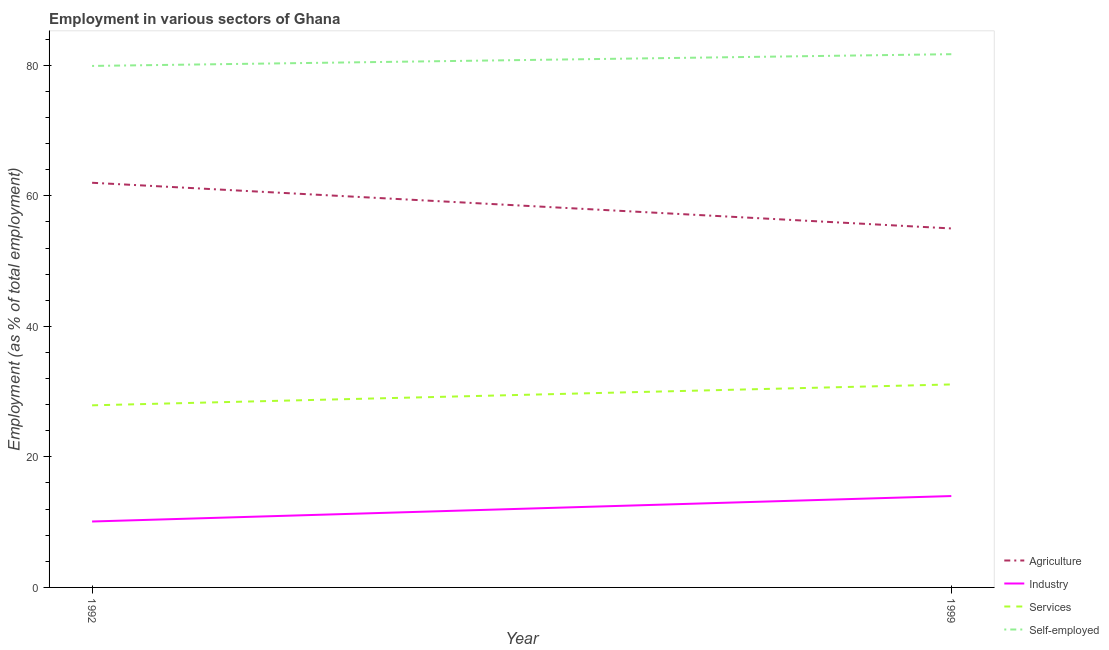How many different coloured lines are there?
Provide a succinct answer. 4. Across all years, what is the maximum percentage of workers in services?
Make the answer very short. 31.1. Across all years, what is the minimum percentage of self employed workers?
Your answer should be very brief. 79.9. In which year was the percentage of workers in industry minimum?
Provide a succinct answer. 1992. What is the total percentage of workers in industry in the graph?
Your answer should be very brief. 24.1. What is the difference between the percentage of workers in agriculture in 1992 and that in 1999?
Make the answer very short. 7. What is the difference between the percentage of workers in agriculture in 1992 and the percentage of workers in services in 1999?
Your response must be concise. 30.9. What is the average percentage of self employed workers per year?
Ensure brevity in your answer.  80.8. In the year 1999, what is the difference between the percentage of workers in agriculture and percentage of workers in services?
Your answer should be compact. 23.9. What is the ratio of the percentage of workers in agriculture in 1992 to that in 1999?
Provide a short and direct response. 1.13. In how many years, is the percentage of workers in agriculture greater than the average percentage of workers in agriculture taken over all years?
Your response must be concise. 1. Does the percentage of self employed workers monotonically increase over the years?
Make the answer very short. Yes. What is the difference between two consecutive major ticks on the Y-axis?
Your response must be concise. 20. Are the values on the major ticks of Y-axis written in scientific E-notation?
Your answer should be compact. No. Does the graph contain any zero values?
Your response must be concise. No. Where does the legend appear in the graph?
Your answer should be compact. Bottom right. How are the legend labels stacked?
Ensure brevity in your answer.  Vertical. What is the title of the graph?
Your answer should be compact. Employment in various sectors of Ghana. Does "Rule based governance" appear as one of the legend labels in the graph?
Make the answer very short. No. What is the label or title of the Y-axis?
Offer a very short reply. Employment (as % of total employment). What is the Employment (as % of total employment) of Industry in 1992?
Ensure brevity in your answer.  10.1. What is the Employment (as % of total employment) of Services in 1992?
Offer a terse response. 27.9. What is the Employment (as % of total employment) in Self-employed in 1992?
Offer a terse response. 79.9. What is the Employment (as % of total employment) in Services in 1999?
Ensure brevity in your answer.  31.1. What is the Employment (as % of total employment) in Self-employed in 1999?
Provide a short and direct response. 81.7. Across all years, what is the maximum Employment (as % of total employment) of Services?
Your answer should be very brief. 31.1. Across all years, what is the maximum Employment (as % of total employment) in Self-employed?
Your answer should be compact. 81.7. Across all years, what is the minimum Employment (as % of total employment) in Industry?
Ensure brevity in your answer.  10.1. Across all years, what is the minimum Employment (as % of total employment) of Services?
Offer a very short reply. 27.9. Across all years, what is the minimum Employment (as % of total employment) in Self-employed?
Provide a short and direct response. 79.9. What is the total Employment (as % of total employment) in Agriculture in the graph?
Give a very brief answer. 117. What is the total Employment (as % of total employment) of Industry in the graph?
Ensure brevity in your answer.  24.1. What is the total Employment (as % of total employment) of Self-employed in the graph?
Provide a succinct answer. 161.6. What is the difference between the Employment (as % of total employment) of Industry in 1992 and that in 1999?
Offer a very short reply. -3.9. What is the difference between the Employment (as % of total employment) of Services in 1992 and that in 1999?
Ensure brevity in your answer.  -3.2. What is the difference between the Employment (as % of total employment) in Self-employed in 1992 and that in 1999?
Ensure brevity in your answer.  -1.8. What is the difference between the Employment (as % of total employment) of Agriculture in 1992 and the Employment (as % of total employment) of Industry in 1999?
Give a very brief answer. 48. What is the difference between the Employment (as % of total employment) in Agriculture in 1992 and the Employment (as % of total employment) in Services in 1999?
Your answer should be very brief. 30.9. What is the difference between the Employment (as % of total employment) in Agriculture in 1992 and the Employment (as % of total employment) in Self-employed in 1999?
Offer a very short reply. -19.7. What is the difference between the Employment (as % of total employment) of Industry in 1992 and the Employment (as % of total employment) of Self-employed in 1999?
Make the answer very short. -71.6. What is the difference between the Employment (as % of total employment) in Services in 1992 and the Employment (as % of total employment) in Self-employed in 1999?
Ensure brevity in your answer.  -53.8. What is the average Employment (as % of total employment) in Agriculture per year?
Ensure brevity in your answer.  58.5. What is the average Employment (as % of total employment) of Industry per year?
Your response must be concise. 12.05. What is the average Employment (as % of total employment) of Services per year?
Provide a short and direct response. 29.5. What is the average Employment (as % of total employment) of Self-employed per year?
Ensure brevity in your answer.  80.8. In the year 1992, what is the difference between the Employment (as % of total employment) of Agriculture and Employment (as % of total employment) of Industry?
Provide a succinct answer. 51.9. In the year 1992, what is the difference between the Employment (as % of total employment) of Agriculture and Employment (as % of total employment) of Services?
Ensure brevity in your answer.  34.1. In the year 1992, what is the difference between the Employment (as % of total employment) of Agriculture and Employment (as % of total employment) of Self-employed?
Provide a succinct answer. -17.9. In the year 1992, what is the difference between the Employment (as % of total employment) of Industry and Employment (as % of total employment) of Services?
Keep it short and to the point. -17.8. In the year 1992, what is the difference between the Employment (as % of total employment) in Industry and Employment (as % of total employment) in Self-employed?
Give a very brief answer. -69.8. In the year 1992, what is the difference between the Employment (as % of total employment) in Services and Employment (as % of total employment) in Self-employed?
Make the answer very short. -52. In the year 1999, what is the difference between the Employment (as % of total employment) of Agriculture and Employment (as % of total employment) of Services?
Make the answer very short. 23.9. In the year 1999, what is the difference between the Employment (as % of total employment) of Agriculture and Employment (as % of total employment) of Self-employed?
Offer a very short reply. -26.7. In the year 1999, what is the difference between the Employment (as % of total employment) of Industry and Employment (as % of total employment) of Services?
Make the answer very short. -17.1. In the year 1999, what is the difference between the Employment (as % of total employment) of Industry and Employment (as % of total employment) of Self-employed?
Offer a terse response. -67.7. In the year 1999, what is the difference between the Employment (as % of total employment) of Services and Employment (as % of total employment) of Self-employed?
Make the answer very short. -50.6. What is the ratio of the Employment (as % of total employment) in Agriculture in 1992 to that in 1999?
Your answer should be very brief. 1.13. What is the ratio of the Employment (as % of total employment) of Industry in 1992 to that in 1999?
Offer a terse response. 0.72. What is the ratio of the Employment (as % of total employment) in Services in 1992 to that in 1999?
Keep it short and to the point. 0.9. What is the ratio of the Employment (as % of total employment) in Self-employed in 1992 to that in 1999?
Your answer should be compact. 0.98. What is the difference between the highest and the second highest Employment (as % of total employment) of Agriculture?
Keep it short and to the point. 7. What is the difference between the highest and the second highest Employment (as % of total employment) of Industry?
Make the answer very short. 3.9. What is the difference between the highest and the second highest Employment (as % of total employment) in Self-employed?
Offer a very short reply. 1.8. What is the difference between the highest and the lowest Employment (as % of total employment) in Industry?
Your answer should be very brief. 3.9. What is the difference between the highest and the lowest Employment (as % of total employment) in Services?
Make the answer very short. 3.2. 